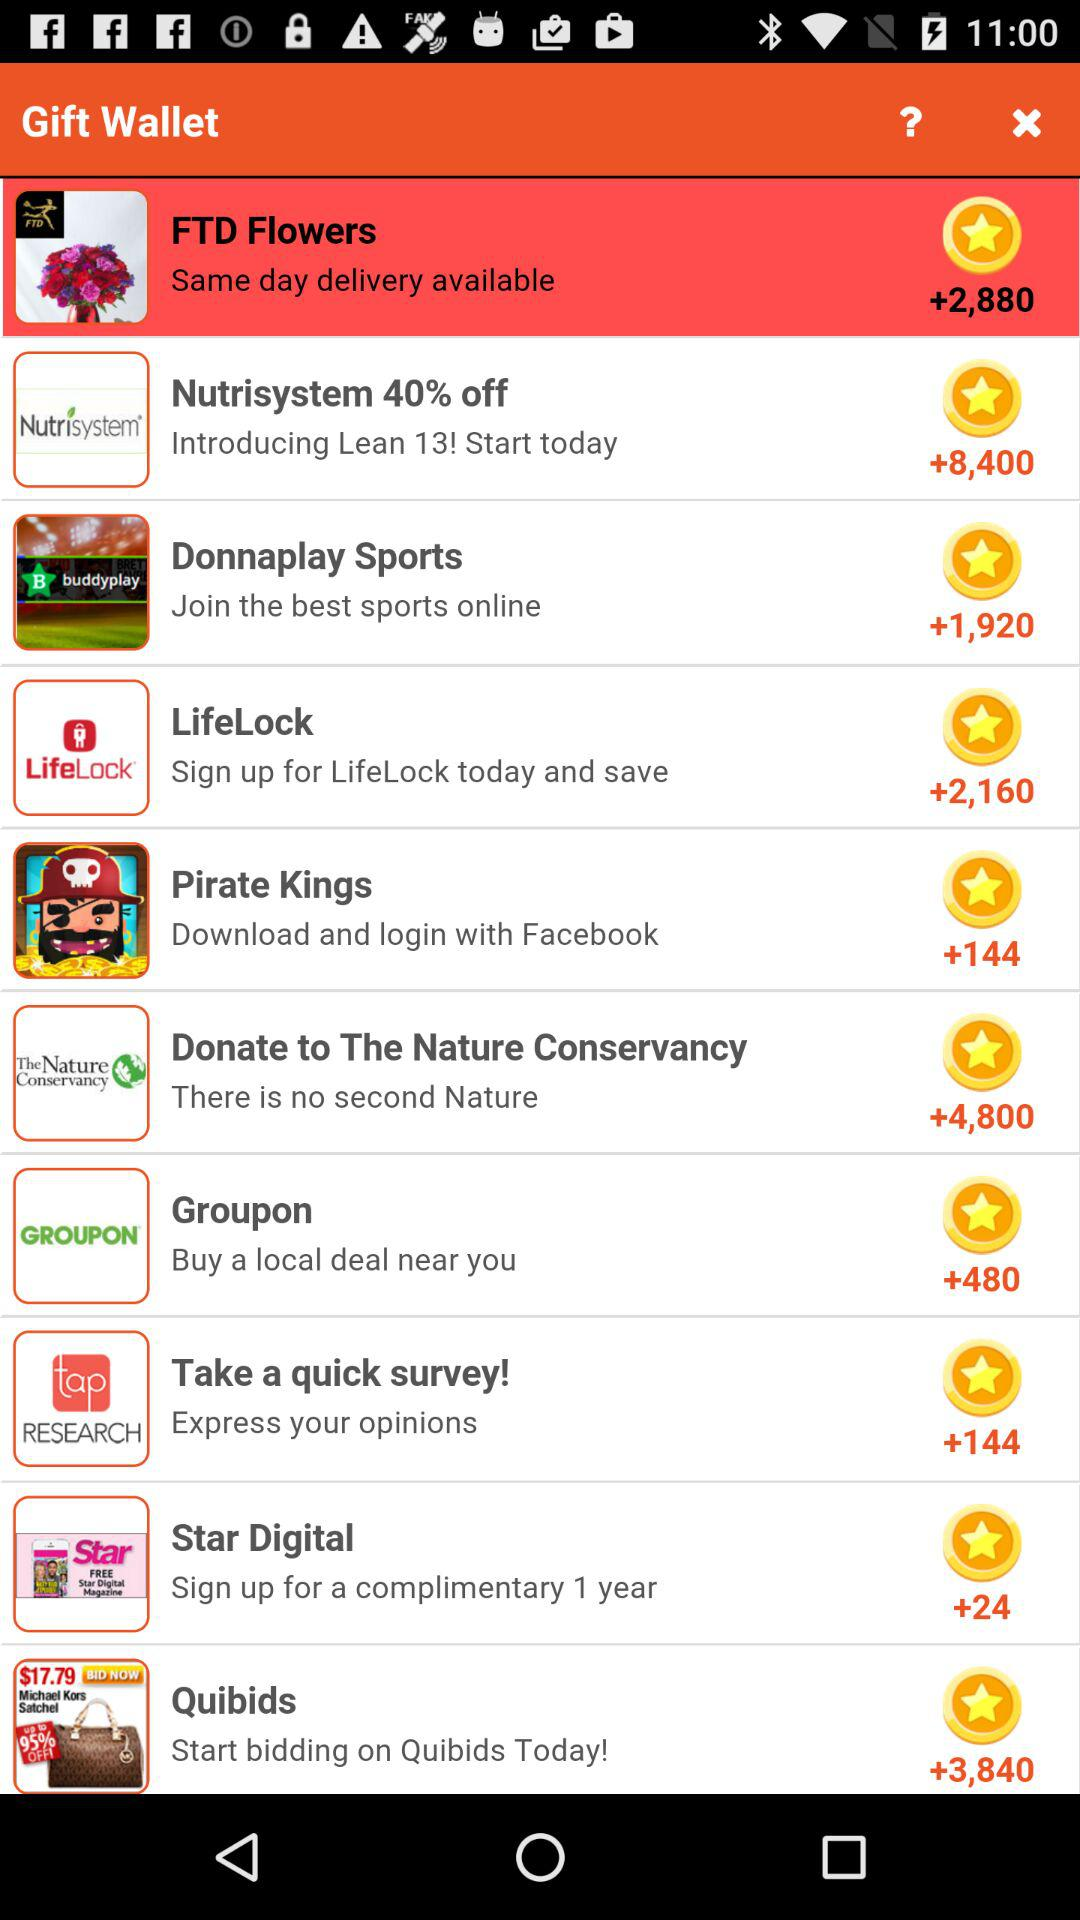"Star Digital Gift" has signed up for how many years? "Star Digital Gift" has signed up for 1 year. 